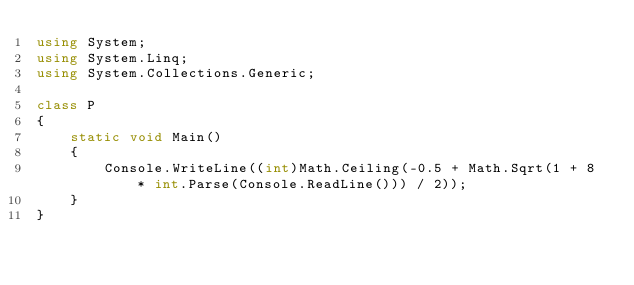<code> <loc_0><loc_0><loc_500><loc_500><_C#_>using System;
using System.Linq;
using System.Collections.Generic;

class P
{
    static void Main()
    {
        Console.WriteLine((int)Math.Ceiling(-0.5 + Math.Sqrt(1 + 8 * int.Parse(Console.ReadLine())) / 2));
    }
}</code> 